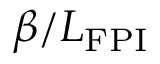Convert formula to latex. <formula><loc_0><loc_0><loc_500><loc_500>\beta / L _ { F P I }</formula> 